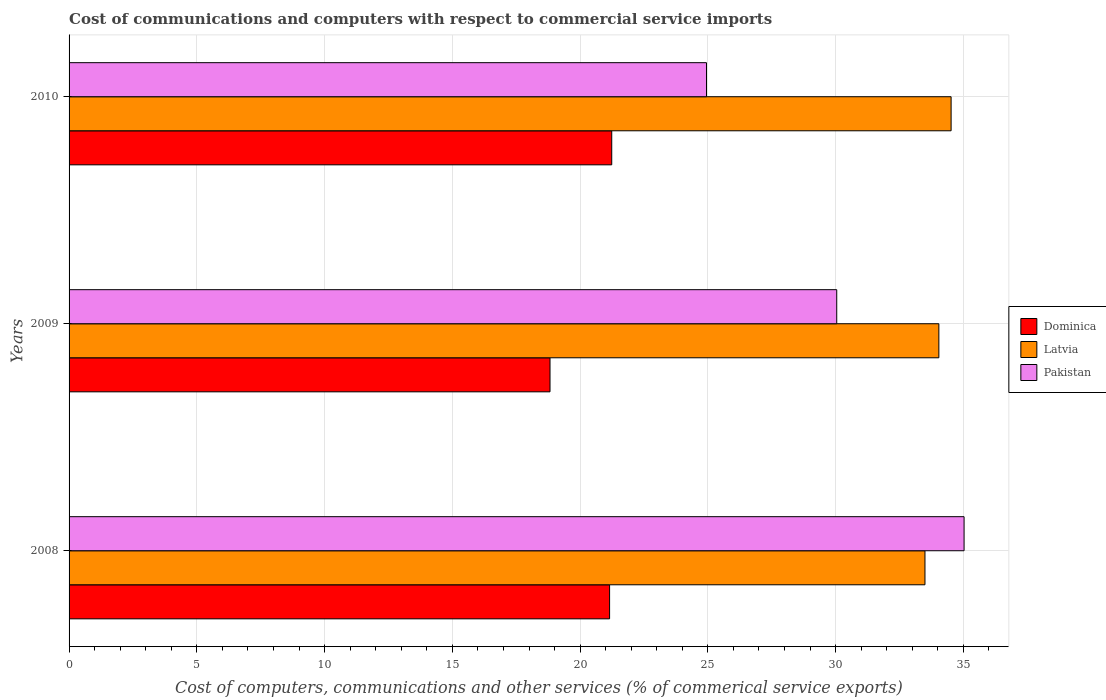How many different coloured bars are there?
Offer a terse response. 3. Are the number of bars on each tick of the Y-axis equal?
Offer a terse response. Yes. What is the label of the 2nd group of bars from the top?
Your answer should be compact. 2009. What is the cost of communications and computers in Latvia in 2009?
Offer a terse response. 34.04. Across all years, what is the maximum cost of communications and computers in Dominica?
Offer a very short reply. 21.24. Across all years, what is the minimum cost of communications and computers in Dominica?
Provide a short and direct response. 18.82. What is the total cost of communications and computers in Pakistan in the graph?
Give a very brief answer. 90.02. What is the difference between the cost of communications and computers in Dominica in 2008 and that in 2009?
Ensure brevity in your answer.  2.33. What is the difference between the cost of communications and computers in Latvia in 2010 and the cost of communications and computers in Pakistan in 2008?
Provide a succinct answer. -0.51. What is the average cost of communications and computers in Dominica per year?
Make the answer very short. 20.4. In the year 2009, what is the difference between the cost of communications and computers in Dominica and cost of communications and computers in Latvia?
Your answer should be compact. -15.22. What is the ratio of the cost of communications and computers in Dominica in 2009 to that in 2010?
Offer a very short reply. 0.89. Is the cost of communications and computers in Dominica in 2009 less than that in 2010?
Make the answer very short. Yes. Is the difference between the cost of communications and computers in Dominica in 2009 and 2010 greater than the difference between the cost of communications and computers in Latvia in 2009 and 2010?
Provide a succinct answer. No. What is the difference between the highest and the second highest cost of communications and computers in Latvia?
Your answer should be compact. 0.48. What is the difference between the highest and the lowest cost of communications and computers in Latvia?
Provide a short and direct response. 1.02. Is the sum of the cost of communications and computers in Latvia in 2008 and 2010 greater than the maximum cost of communications and computers in Pakistan across all years?
Your answer should be very brief. Yes. What does the 3rd bar from the top in 2010 represents?
Your answer should be very brief. Dominica. What does the 1st bar from the bottom in 2010 represents?
Provide a short and direct response. Dominica. Are all the bars in the graph horizontal?
Ensure brevity in your answer.  Yes. How many years are there in the graph?
Your response must be concise. 3. Are the values on the major ticks of X-axis written in scientific E-notation?
Provide a succinct answer. No. Does the graph contain any zero values?
Offer a terse response. No. Where does the legend appear in the graph?
Keep it short and to the point. Center right. How many legend labels are there?
Offer a terse response. 3. How are the legend labels stacked?
Ensure brevity in your answer.  Vertical. What is the title of the graph?
Your answer should be very brief. Cost of communications and computers with respect to commercial service imports. What is the label or title of the X-axis?
Offer a terse response. Cost of computers, communications and other services (% of commerical service exports). What is the Cost of computers, communications and other services (% of commerical service exports) in Dominica in 2008?
Your response must be concise. 21.15. What is the Cost of computers, communications and other services (% of commerical service exports) of Latvia in 2008?
Ensure brevity in your answer.  33.5. What is the Cost of computers, communications and other services (% of commerical service exports) in Pakistan in 2008?
Provide a succinct answer. 35.03. What is the Cost of computers, communications and other services (% of commerical service exports) in Dominica in 2009?
Your answer should be very brief. 18.82. What is the Cost of computers, communications and other services (% of commerical service exports) of Latvia in 2009?
Ensure brevity in your answer.  34.04. What is the Cost of computers, communications and other services (% of commerical service exports) in Pakistan in 2009?
Offer a very short reply. 30.04. What is the Cost of computers, communications and other services (% of commerical service exports) in Dominica in 2010?
Give a very brief answer. 21.24. What is the Cost of computers, communications and other services (% of commerical service exports) in Latvia in 2010?
Keep it short and to the point. 34.52. What is the Cost of computers, communications and other services (% of commerical service exports) in Pakistan in 2010?
Give a very brief answer. 24.95. Across all years, what is the maximum Cost of computers, communications and other services (% of commerical service exports) of Dominica?
Make the answer very short. 21.24. Across all years, what is the maximum Cost of computers, communications and other services (% of commerical service exports) of Latvia?
Offer a terse response. 34.52. Across all years, what is the maximum Cost of computers, communications and other services (% of commerical service exports) of Pakistan?
Offer a terse response. 35.03. Across all years, what is the minimum Cost of computers, communications and other services (% of commerical service exports) in Dominica?
Ensure brevity in your answer.  18.82. Across all years, what is the minimum Cost of computers, communications and other services (% of commerical service exports) in Latvia?
Ensure brevity in your answer.  33.5. Across all years, what is the minimum Cost of computers, communications and other services (% of commerical service exports) in Pakistan?
Ensure brevity in your answer.  24.95. What is the total Cost of computers, communications and other services (% of commerical service exports) of Dominica in the graph?
Make the answer very short. 61.21. What is the total Cost of computers, communications and other services (% of commerical service exports) of Latvia in the graph?
Your answer should be very brief. 102.06. What is the total Cost of computers, communications and other services (% of commerical service exports) in Pakistan in the graph?
Your response must be concise. 90.02. What is the difference between the Cost of computers, communications and other services (% of commerical service exports) of Dominica in 2008 and that in 2009?
Ensure brevity in your answer.  2.33. What is the difference between the Cost of computers, communications and other services (% of commerical service exports) of Latvia in 2008 and that in 2009?
Offer a terse response. -0.54. What is the difference between the Cost of computers, communications and other services (% of commerical service exports) in Pakistan in 2008 and that in 2009?
Keep it short and to the point. 4.98. What is the difference between the Cost of computers, communications and other services (% of commerical service exports) of Dominica in 2008 and that in 2010?
Your answer should be very brief. -0.08. What is the difference between the Cost of computers, communications and other services (% of commerical service exports) in Latvia in 2008 and that in 2010?
Ensure brevity in your answer.  -1.02. What is the difference between the Cost of computers, communications and other services (% of commerical service exports) of Pakistan in 2008 and that in 2010?
Provide a short and direct response. 10.08. What is the difference between the Cost of computers, communications and other services (% of commerical service exports) of Dominica in 2009 and that in 2010?
Provide a short and direct response. -2.42. What is the difference between the Cost of computers, communications and other services (% of commerical service exports) in Latvia in 2009 and that in 2010?
Your response must be concise. -0.48. What is the difference between the Cost of computers, communications and other services (% of commerical service exports) of Pakistan in 2009 and that in 2010?
Your answer should be very brief. 5.1. What is the difference between the Cost of computers, communications and other services (% of commerical service exports) in Dominica in 2008 and the Cost of computers, communications and other services (% of commerical service exports) in Latvia in 2009?
Your response must be concise. -12.89. What is the difference between the Cost of computers, communications and other services (% of commerical service exports) of Dominica in 2008 and the Cost of computers, communications and other services (% of commerical service exports) of Pakistan in 2009?
Your answer should be compact. -8.89. What is the difference between the Cost of computers, communications and other services (% of commerical service exports) of Latvia in 2008 and the Cost of computers, communications and other services (% of commerical service exports) of Pakistan in 2009?
Offer a very short reply. 3.45. What is the difference between the Cost of computers, communications and other services (% of commerical service exports) of Dominica in 2008 and the Cost of computers, communications and other services (% of commerical service exports) of Latvia in 2010?
Provide a succinct answer. -13.37. What is the difference between the Cost of computers, communications and other services (% of commerical service exports) in Dominica in 2008 and the Cost of computers, communications and other services (% of commerical service exports) in Pakistan in 2010?
Ensure brevity in your answer.  -3.79. What is the difference between the Cost of computers, communications and other services (% of commerical service exports) in Latvia in 2008 and the Cost of computers, communications and other services (% of commerical service exports) in Pakistan in 2010?
Give a very brief answer. 8.55. What is the difference between the Cost of computers, communications and other services (% of commerical service exports) of Dominica in 2009 and the Cost of computers, communications and other services (% of commerical service exports) of Latvia in 2010?
Ensure brevity in your answer.  -15.7. What is the difference between the Cost of computers, communications and other services (% of commerical service exports) of Dominica in 2009 and the Cost of computers, communications and other services (% of commerical service exports) of Pakistan in 2010?
Keep it short and to the point. -6.12. What is the difference between the Cost of computers, communications and other services (% of commerical service exports) in Latvia in 2009 and the Cost of computers, communications and other services (% of commerical service exports) in Pakistan in 2010?
Offer a terse response. 9.09. What is the average Cost of computers, communications and other services (% of commerical service exports) of Dominica per year?
Provide a short and direct response. 20.4. What is the average Cost of computers, communications and other services (% of commerical service exports) in Latvia per year?
Provide a succinct answer. 34.02. What is the average Cost of computers, communications and other services (% of commerical service exports) of Pakistan per year?
Offer a terse response. 30.01. In the year 2008, what is the difference between the Cost of computers, communications and other services (% of commerical service exports) of Dominica and Cost of computers, communications and other services (% of commerical service exports) of Latvia?
Offer a terse response. -12.34. In the year 2008, what is the difference between the Cost of computers, communications and other services (% of commerical service exports) of Dominica and Cost of computers, communications and other services (% of commerical service exports) of Pakistan?
Provide a short and direct response. -13.87. In the year 2008, what is the difference between the Cost of computers, communications and other services (% of commerical service exports) of Latvia and Cost of computers, communications and other services (% of commerical service exports) of Pakistan?
Offer a very short reply. -1.53. In the year 2009, what is the difference between the Cost of computers, communications and other services (% of commerical service exports) in Dominica and Cost of computers, communications and other services (% of commerical service exports) in Latvia?
Offer a terse response. -15.22. In the year 2009, what is the difference between the Cost of computers, communications and other services (% of commerical service exports) in Dominica and Cost of computers, communications and other services (% of commerical service exports) in Pakistan?
Provide a succinct answer. -11.22. In the year 2009, what is the difference between the Cost of computers, communications and other services (% of commerical service exports) in Latvia and Cost of computers, communications and other services (% of commerical service exports) in Pakistan?
Ensure brevity in your answer.  4. In the year 2010, what is the difference between the Cost of computers, communications and other services (% of commerical service exports) of Dominica and Cost of computers, communications and other services (% of commerical service exports) of Latvia?
Offer a terse response. -13.28. In the year 2010, what is the difference between the Cost of computers, communications and other services (% of commerical service exports) in Dominica and Cost of computers, communications and other services (% of commerical service exports) in Pakistan?
Your response must be concise. -3.71. In the year 2010, what is the difference between the Cost of computers, communications and other services (% of commerical service exports) of Latvia and Cost of computers, communications and other services (% of commerical service exports) of Pakistan?
Give a very brief answer. 9.57. What is the ratio of the Cost of computers, communications and other services (% of commerical service exports) of Dominica in 2008 to that in 2009?
Provide a succinct answer. 1.12. What is the ratio of the Cost of computers, communications and other services (% of commerical service exports) of Pakistan in 2008 to that in 2009?
Your answer should be very brief. 1.17. What is the ratio of the Cost of computers, communications and other services (% of commerical service exports) in Dominica in 2008 to that in 2010?
Offer a terse response. 1. What is the ratio of the Cost of computers, communications and other services (% of commerical service exports) in Latvia in 2008 to that in 2010?
Give a very brief answer. 0.97. What is the ratio of the Cost of computers, communications and other services (% of commerical service exports) in Pakistan in 2008 to that in 2010?
Ensure brevity in your answer.  1.4. What is the ratio of the Cost of computers, communications and other services (% of commerical service exports) in Dominica in 2009 to that in 2010?
Your answer should be compact. 0.89. What is the ratio of the Cost of computers, communications and other services (% of commerical service exports) in Latvia in 2009 to that in 2010?
Make the answer very short. 0.99. What is the ratio of the Cost of computers, communications and other services (% of commerical service exports) in Pakistan in 2009 to that in 2010?
Ensure brevity in your answer.  1.2. What is the difference between the highest and the second highest Cost of computers, communications and other services (% of commerical service exports) of Dominica?
Your answer should be compact. 0.08. What is the difference between the highest and the second highest Cost of computers, communications and other services (% of commerical service exports) of Latvia?
Keep it short and to the point. 0.48. What is the difference between the highest and the second highest Cost of computers, communications and other services (% of commerical service exports) in Pakistan?
Ensure brevity in your answer.  4.98. What is the difference between the highest and the lowest Cost of computers, communications and other services (% of commerical service exports) of Dominica?
Make the answer very short. 2.42. What is the difference between the highest and the lowest Cost of computers, communications and other services (% of commerical service exports) of Latvia?
Offer a terse response. 1.02. What is the difference between the highest and the lowest Cost of computers, communications and other services (% of commerical service exports) in Pakistan?
Give a very brief answer. 10.08. 